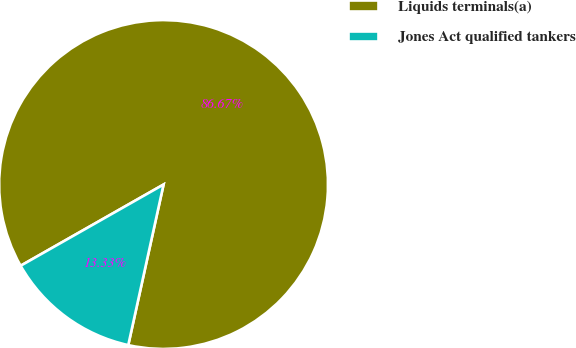Convert chart. <chart><loc_0><loc_0><loc_500><loc_500><pie_chart><fcel>Liquids terminals(a)<fcel>Jones Act qualified tankers<nl><fcel>86.67%<fcel>13.33%<nl></chart> 